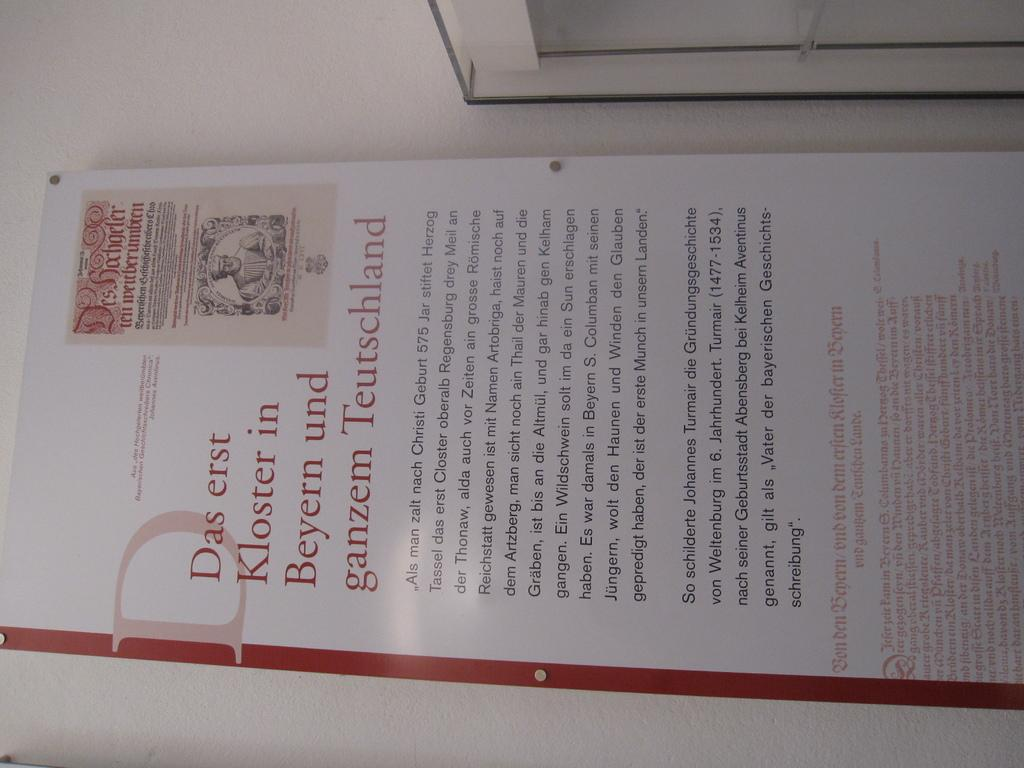<image>
Provide a brief description of the given image. A sign mentions Kloster in Beyern, written in red text. 